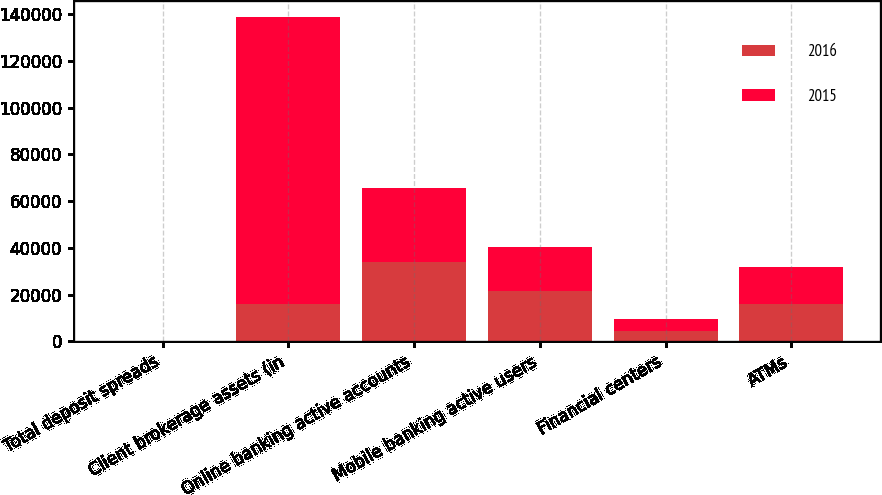<chart> <loc_0><loc_0><loc_500><loc_500><stacked_bar_chart><ecel><fcel>Total deposit spreads<fcel>Client brokerage assets (in<fcel>Online banking active accounts<fcel>Mobile banking active users<fcel>Financial centers<fcel>ATMs<nl><fcel>2016<fcel>1.65<fcel>16038<fcel>33811<fcel>21648<fcel>4579<fcel>15928<nl><fcel>2015<fcel>1.62<fcel>122721<fcel>31674<fcel>18705<fcel>4726<fcel>16038<nl></chart> 